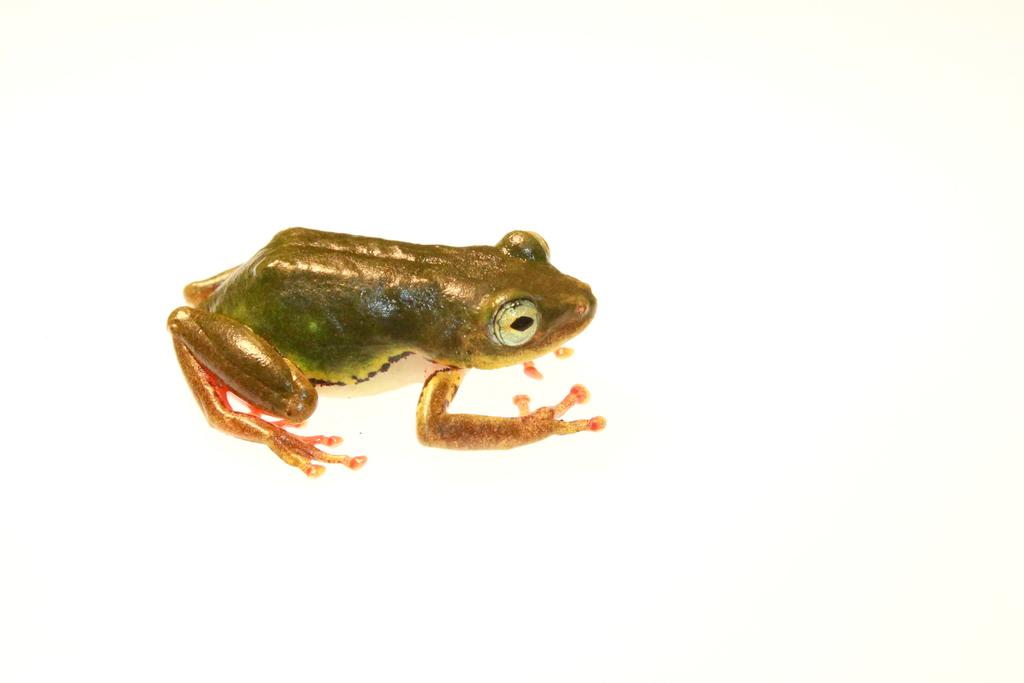What type of animal is present in the image? There is a frog in the image. What type of alarm can be seen in the image? There is no alarm present in the image; it features a frog. 